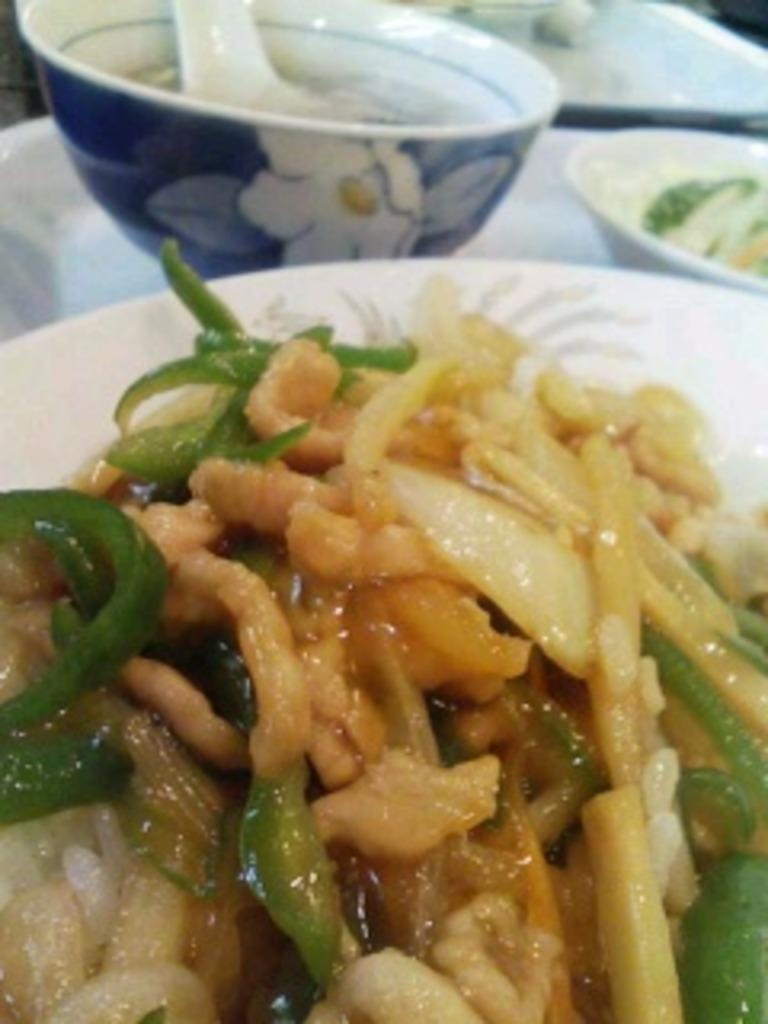What type of food can be seen in the image? The food in the image is in yellow and green colors. What color is the bowl that is visible on the table in the image? The bowl on the table is blue. What shape is the mask in the image? There is no mask present in the image. 